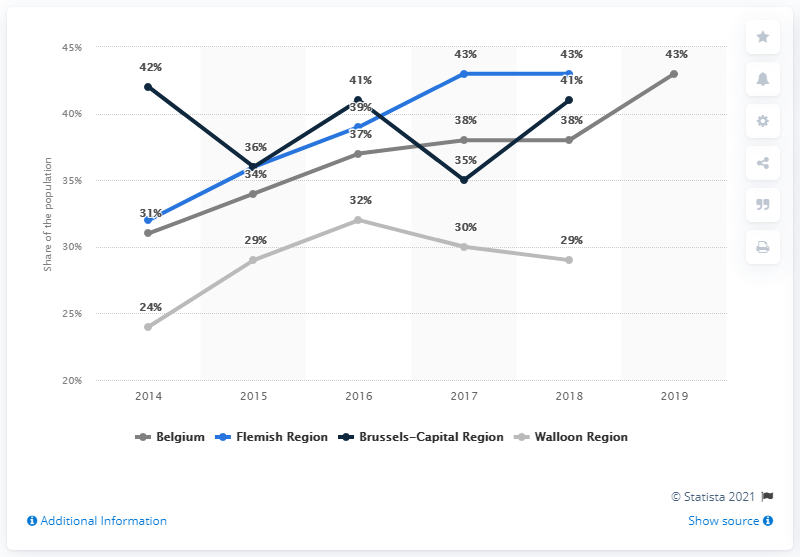Give some essential details in this illustration. The Walloon Region has the lowest value. The ratio of the largest value of the light blue and gray graph is 1.023809524... 